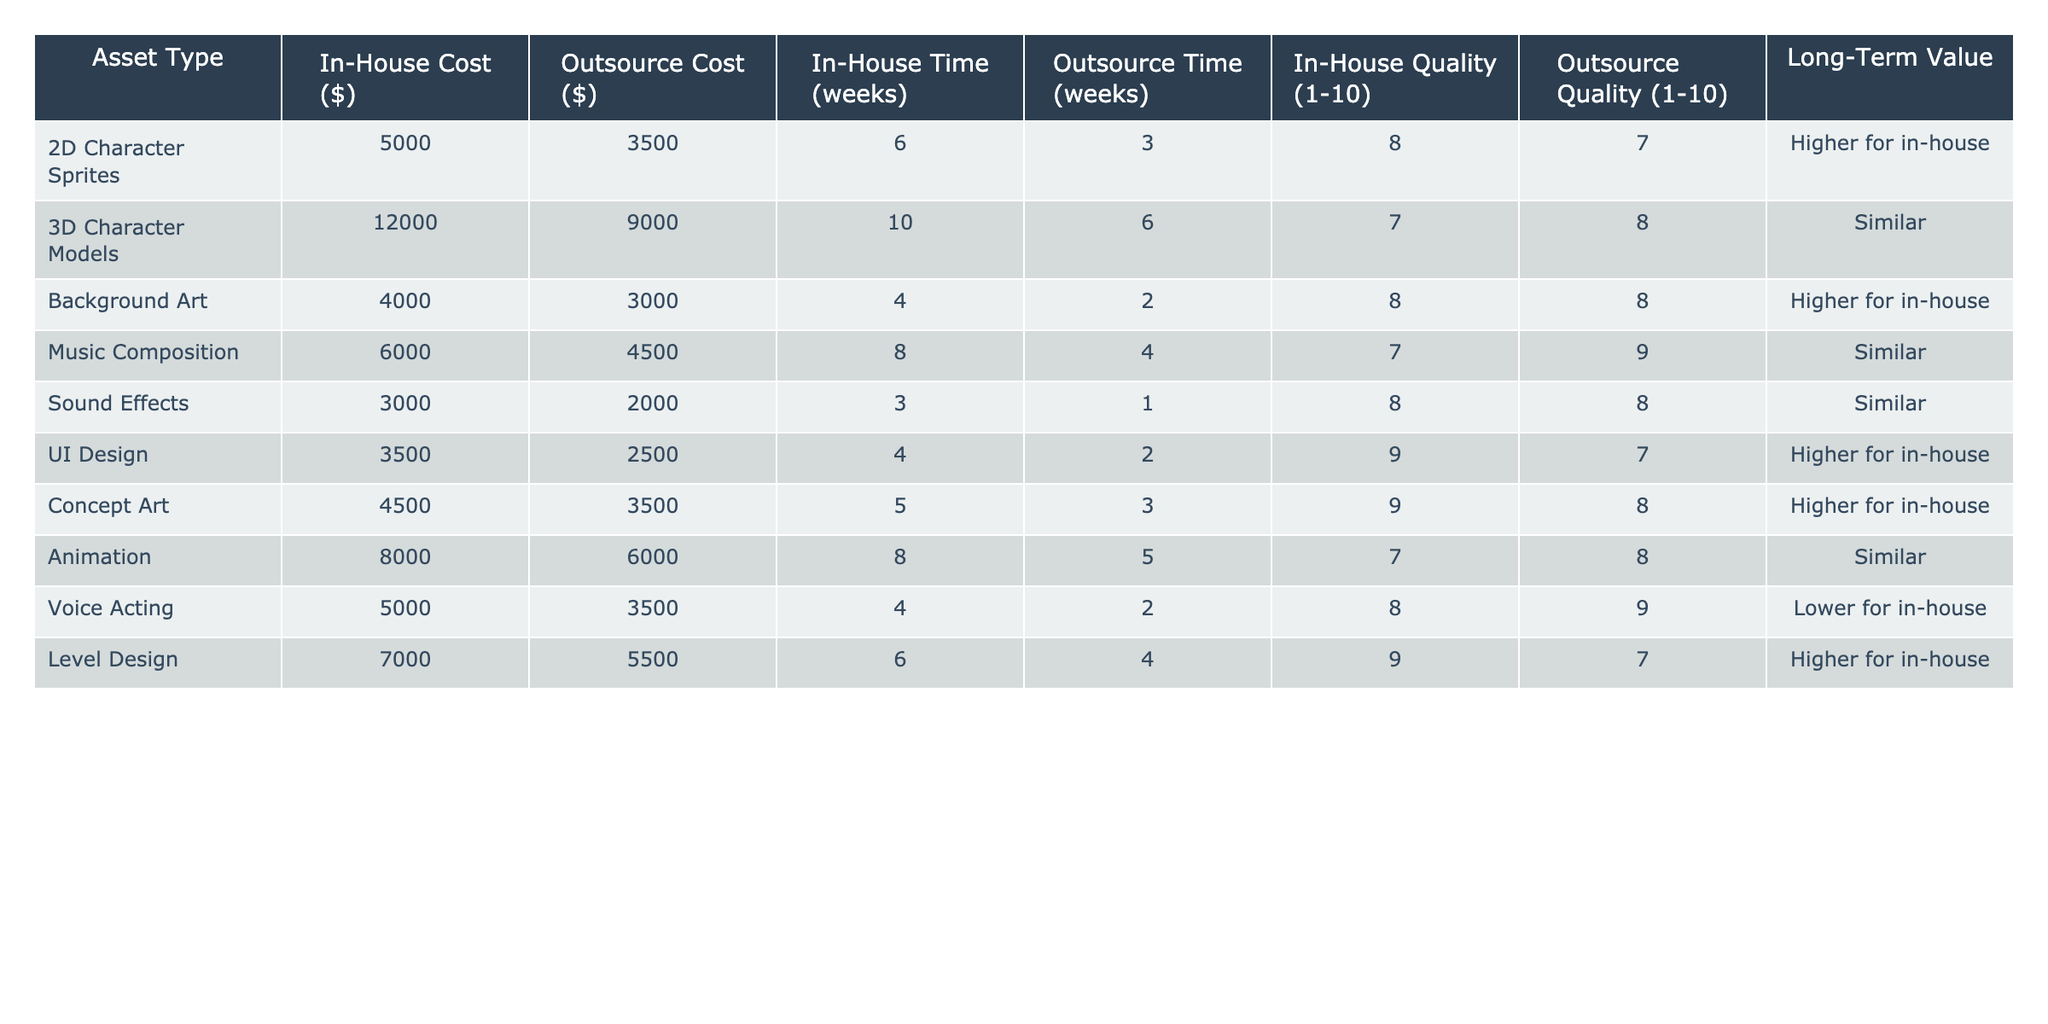What is the cost of outsourcing 3D character models? The table lists the outsource cost for 3D character models, which is $9000.
Answer: $9000 What is the in-house quality rating for UI design? The table shows the in-house quality rating for UI design to be 9.
Answer: 9 Which asset type has the highest in-house cost? The highest in-house cost in the table is for 3D character models, which is $12000.
Answer: 3D Character Models What is the average outsource cost for all assets? To find the average outsource cost, add all the outsource costs ($3500 + $9000 + $3000 + $4500 + $2000 + $2500 + $3500 + $6000 + $3500 + $5500) = $30000. Then divide by the number of asset types (10): $30000/10 = $3000.
Answer: $3000 Is the long-term value for music composition higher if done in-house? The table states that the long-term value for music composition is similar for both in-house and outsourcing.
Answer: No Which asset has a lower quality rating when outsourced compared to in-house? Looking at the table, the voice acting asset has a quality rating of 8 for in-house but 9 for outsourcing, indicating a lower quality rating when done in-house.
Answer: Voice Acting What is the total time (in weeks) required for in-house development of all assets? Adding the in-house times: 6 + 10 + 4 + 8 + 3 + 4 + 5 + 8 + 4 + 6 = 58 weeks.
Answer: 58 weeks Which asset provides a higher long-term value when developed in-house compared to outsourcing? Referring to the table, 2D character sprites, background art, UI design, concept art, and level design all indicate a higher long-term value for in-house development.
Answer: 2D Character Sprites, Background Art, UI Design, Concept Art, Level Design What is the difference in cost between outsourcing and in-house for sound effects? The in-house cost for sound effects is $3000, and the outsource cost is $2000. The difference is $3000 - $2000 = $1000.
Answer: $1000 Is it more time-efficient to outsource level design? The table shows that outsourcing level design takes 4 weeks, while in-house takes 6 weeks, therefore outsourcing is more time-efficient.
Answer: Yes 